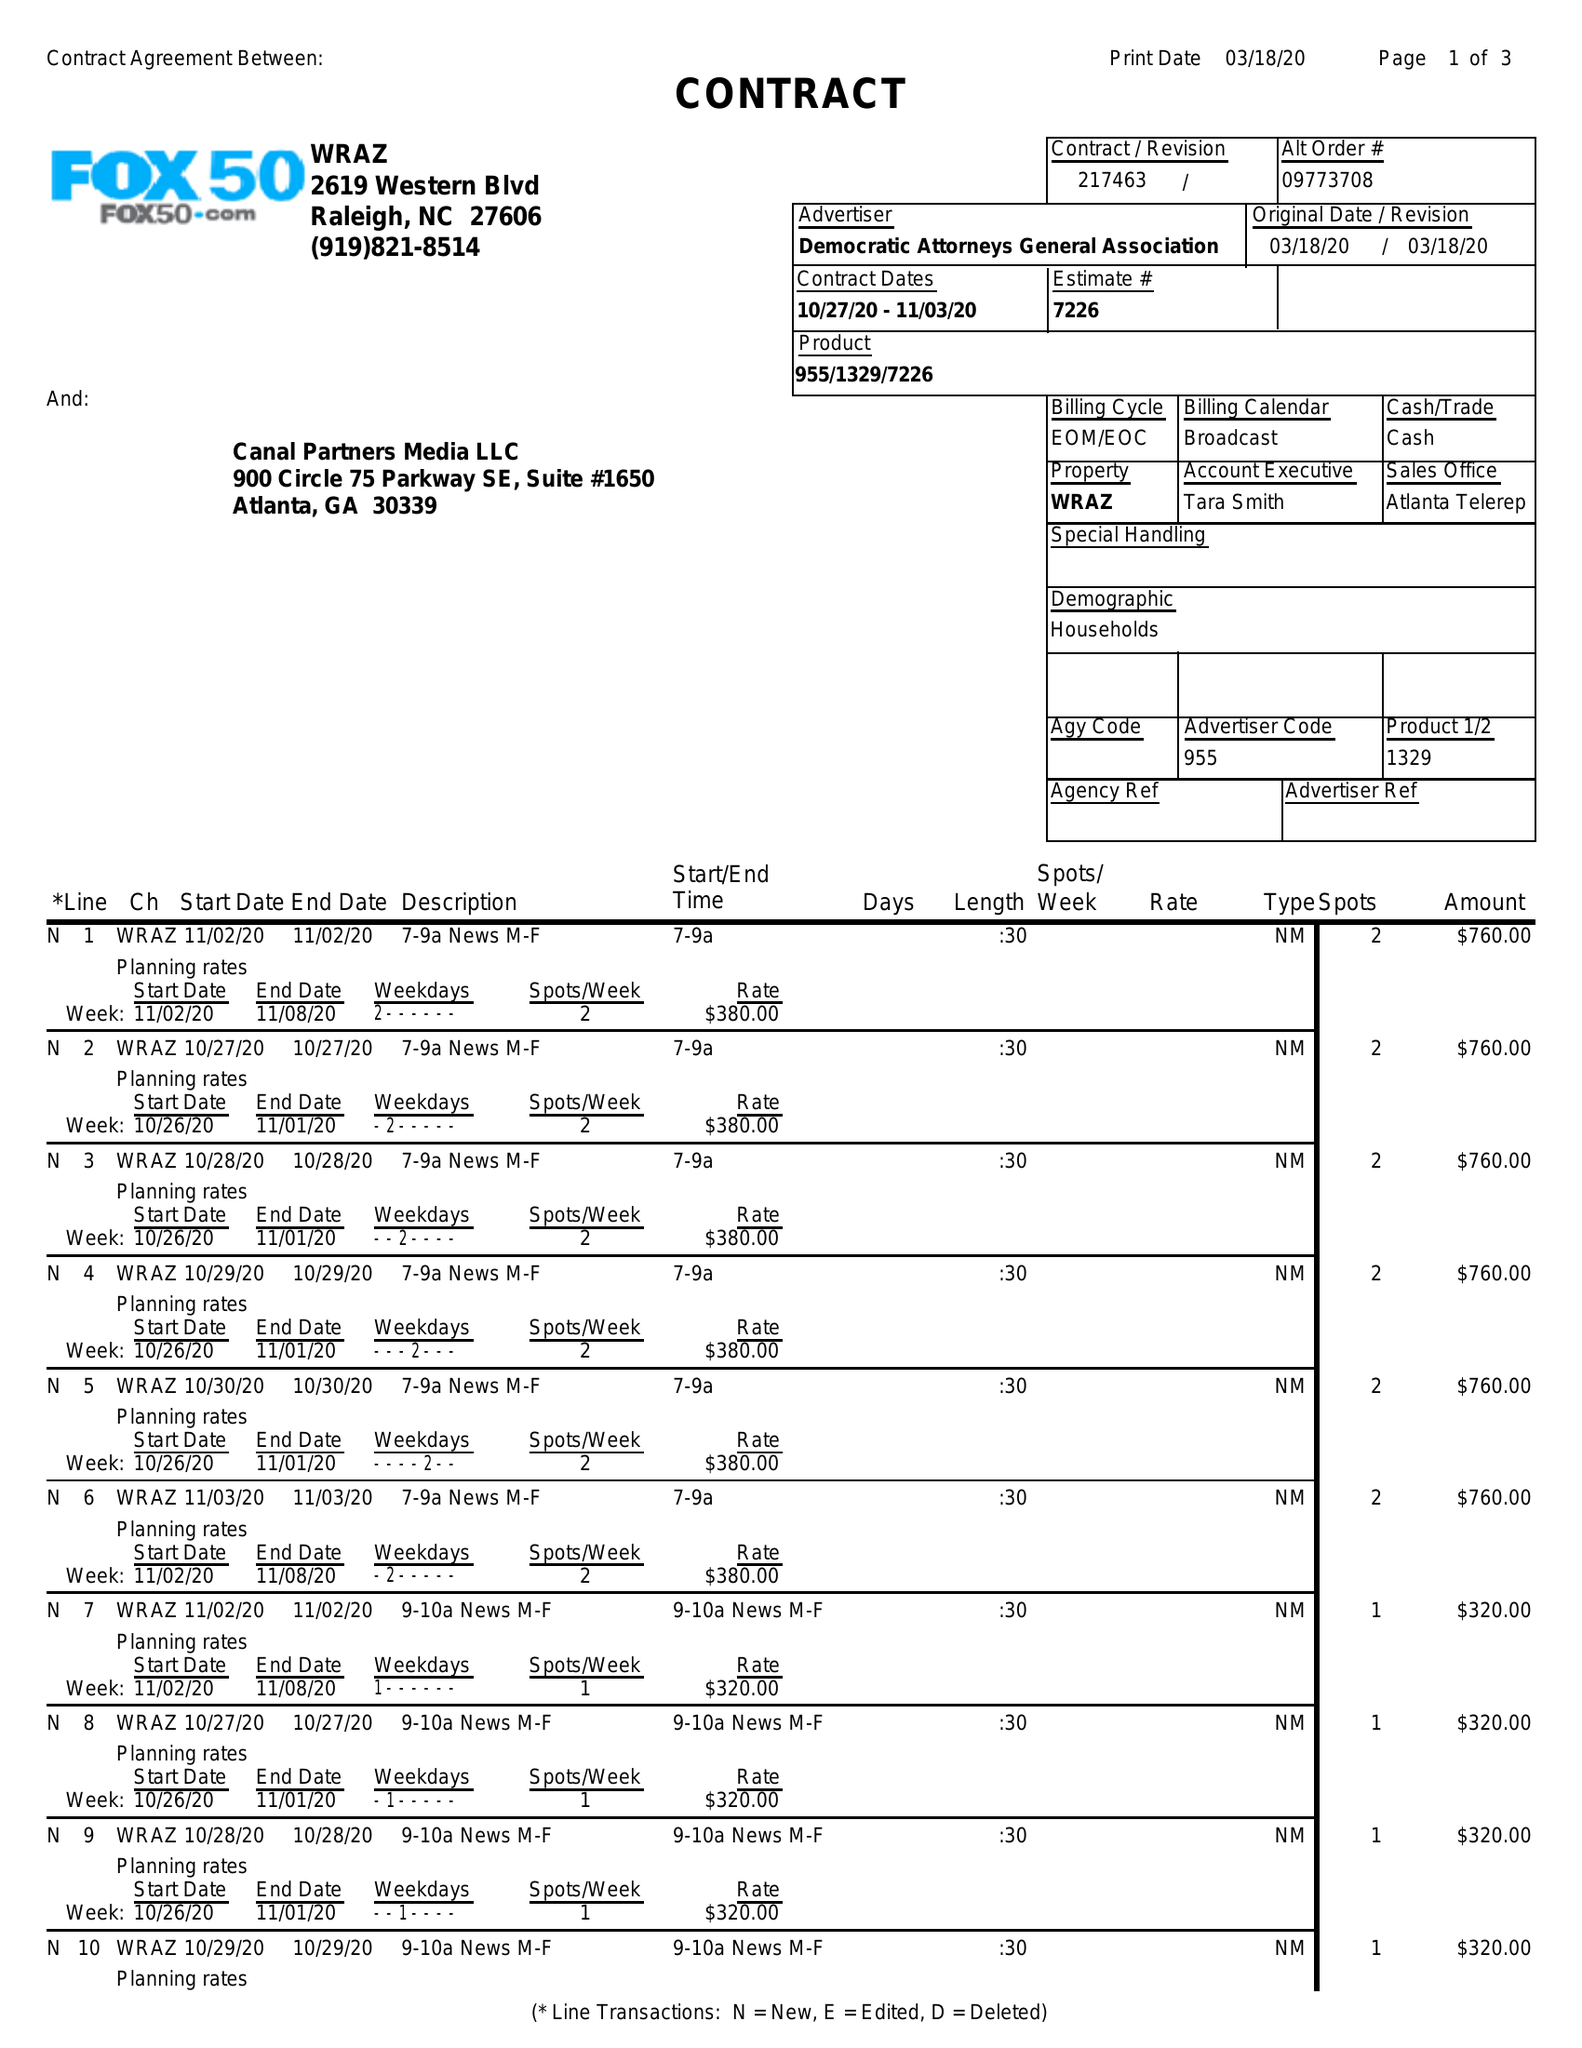What is the value for the gross_amount?
Answer the question using a single word or phrase. 10020.00 